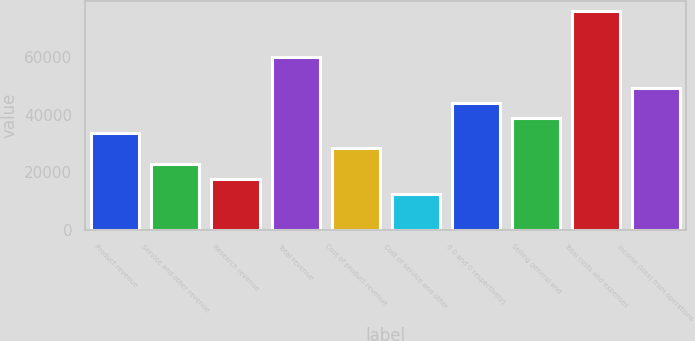Convert chart. <chart><loc_0><loc_0><loc_500><loc_500><bar_chart><fcel>Product revenue<fcel>Service and other revenue<fcel>Research revenue<fcel>Total revenue<fcel>Cost of product revenue<fcel>Cost of service and other<fcel>0 0 and 0 respectively)<fcel>Selling general and<fcel>Total costs and expenses<fcel>Income (loss) from operations<nl><fcel>33522.6<fcel>22955.4<fcel>17671.8<fcel>59940.6<fcel>28239<fcel>12388.2<fcel>44089.8<fcel>38806.2<fcel>75791.4<fcel>49373.4<nl></chart> 